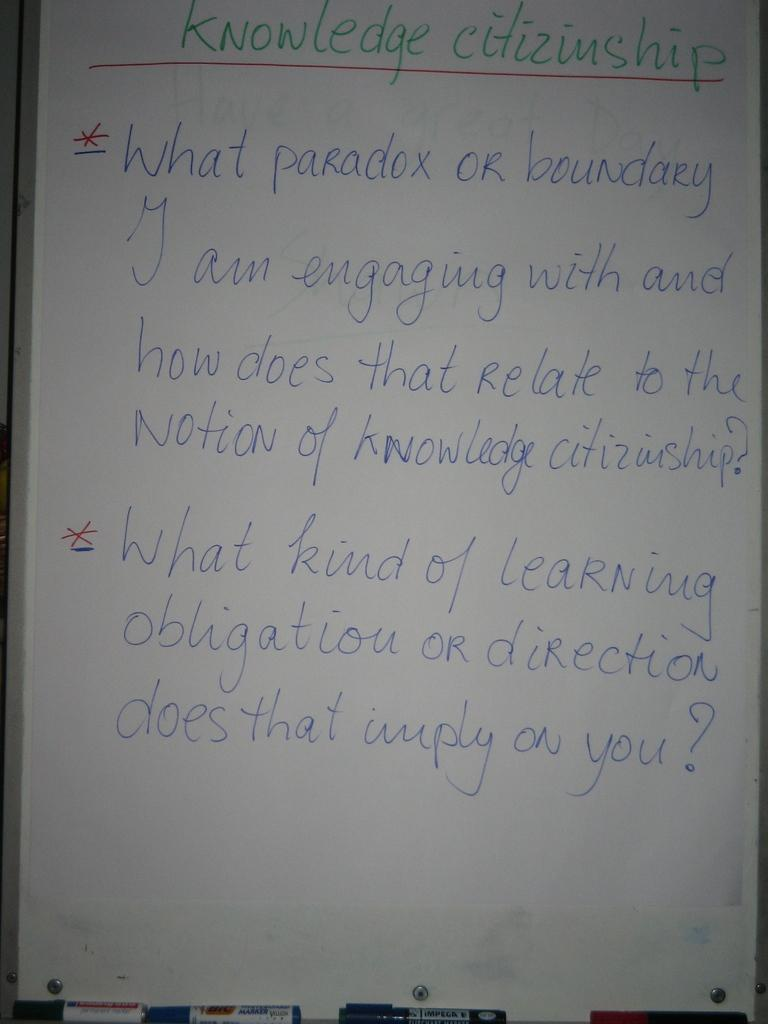<image>
Render a clear and concise summary of the photo. A list called "Knowledge Citizenship" is written on white paper. 